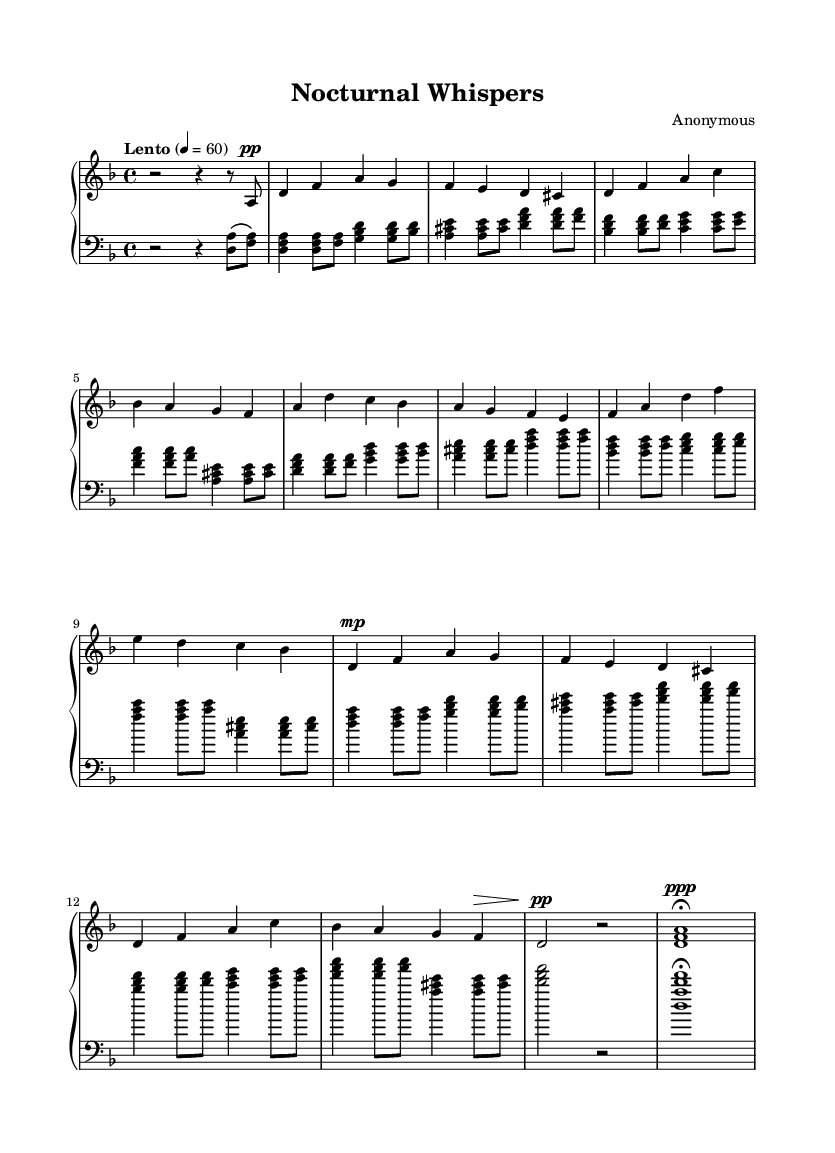What is the key signature of this music? The key signature is D minor, which has one flat (B-flat). It can be determined by looking at the key signature section at the beginning of the staff, where the B-flat is indicated.
Answer: D minor What is the time signature of this piece? The time signature is 4/4, as indicated in the beginning of the sheet music. This means there are four beats per measure and the quarter note gets one beat.
Answer: 4/4 What is the tempo marking for this piece? The tempo marking is "Lento," which indicates a slow tempo. It is indicated in the tempo section at the start of the music, along with a specific metronome marking of 60 beats per minute.
Answer: Lento How many sections are in this composition? The composition has three main sections: A, B, and A' with a coda at the end. Each section can be identified in the structure of the piece, as labeled in the music.
Answer: Four What dynamic marking is indicated during the A' section? The dynamic marking during the A' section is "mp," meaning "mezzo-piano," which indicates a moderately soft volume. This can be observed in the notation for that section in the right hand.
Answer: mp Which left hand chord occurs most frequently in the A section? The chord <d f a> appears most frequently in the A section, as it is consistently used throughout the left-hand part in that section. It can be recognized by locating the specific pitches in the notation.
Answer: <d f a> What kind of texture is primarily used in this piece? The piece primarily features a homophonic texture, where the right hand plays the melody while the left hand provides harmonic support. This can be inferred from the distinction between the melodic line and the accompanying chords throughout the music.
Answer: Homophonic 